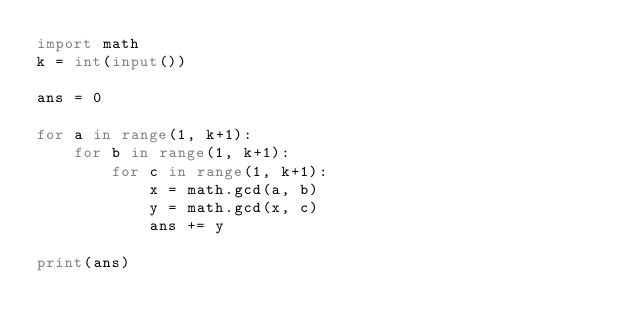<code> <loc_0><loc_0><loc_500><loc_500><_Python_>import math
k = int(input())

ans = 0

for a in range(1, k+1):
    for b in range(1, k+1):
        for c in range(1, k+1):
            x = math.gcd(a, b)
            y = math.gcd(x, c)
            ans += y

print(ans)
</code> 